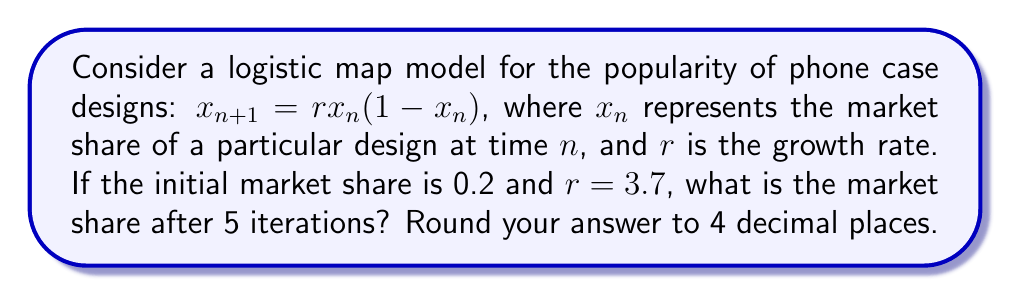Show me your answer to this math problem. Let's iterate the logistic map equation for 5 steps:

1. Initial value: $x_0 = 0.2$

2. First iteration:
   $x_1 = 3.7 \cdot 0.2 \cdot (1-0.2) = 0.592$

3. Second iteration:
   $x_2 = 3.7 \cdot 0.592 \cdot (1-0.592) = 0.8930$

4. Third iteration:
   $x_3 = 3.7 \cdot 0.8930 \cdot (1-0.8930) = 0.3537$

5. Fourth iteration:
   $x_4 = 3.7 \cdot 0.3537 \cdot (1-0.3537) = 0.8455$

6. Fifth iteration:
   $x_5 = 3.7 \cdot 0.8455 \cdot (1-0.8455) = 0.4845$

Rounding to 4 decimal places: 0.4845
Answer: 0.4845 